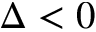<formula> <loc_0><loc_0><loc_500><loc_500>\Delta < 0</formula> 